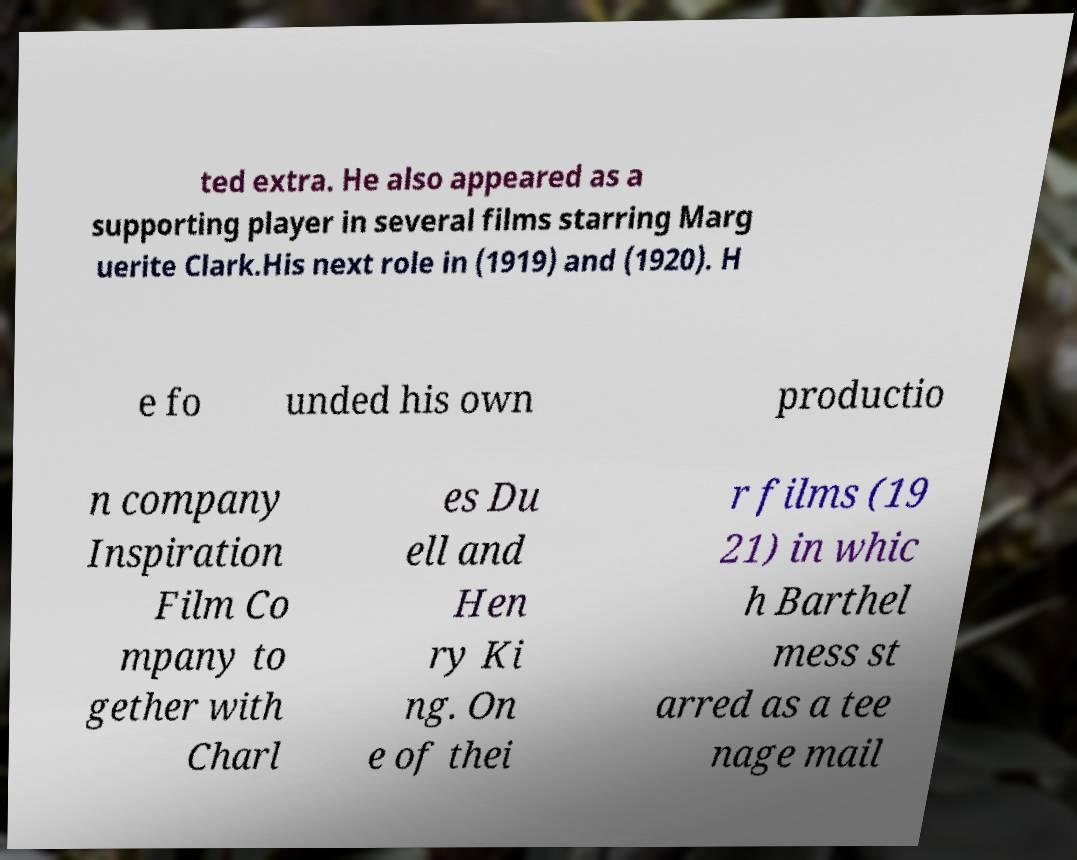Could you assist in decoding the text presented in this image and type it out clearly? ted extra. He also appeared as a supporting player in several films starring Marg uerite Clark.His next role in (1919) and (1920). H e fo unded his own productio n company Inspiration Film Co mpany to gether with Charl es Du ell and Hen ry Ki ng. On e of thei r films (19 21) in whic h Barthel mess st arred as a tee nage mail 